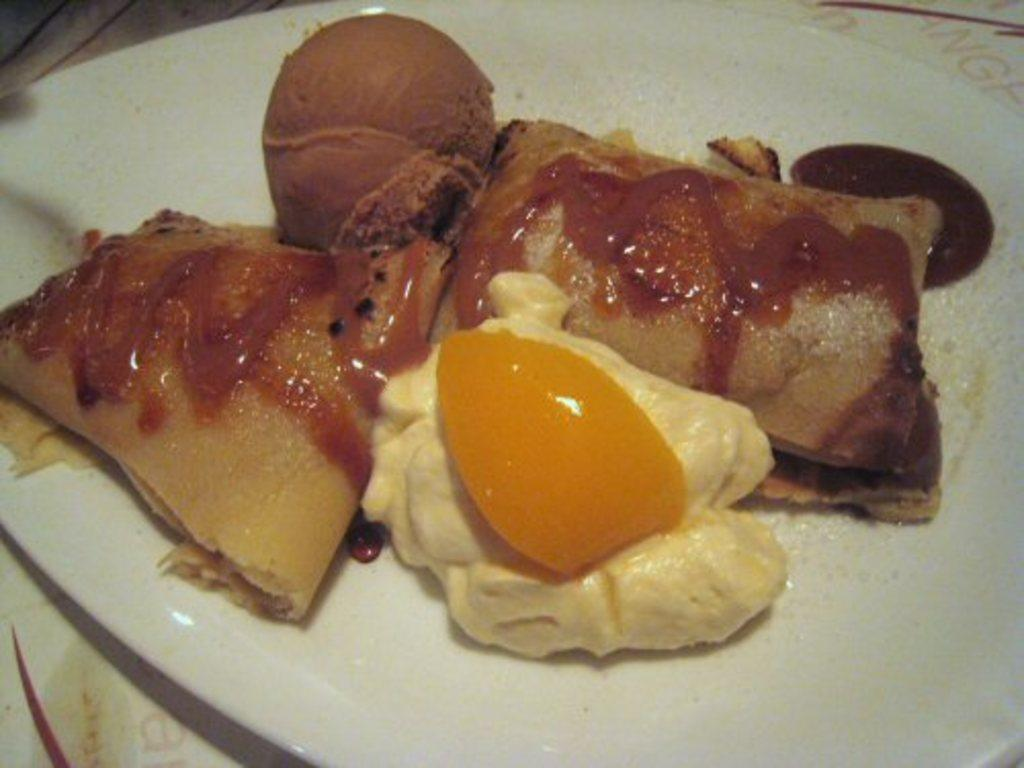How close is the view of the image? The image is zoomed in. What is the main object in the foreground of the image? There is a white color palette in the foreground of the image. What can be found on the palette? The palette contains food items. Can you see the root of the tree in the image? There is no tree or root present in the image; it features a white color palette with food items. How does the person in the image touch the food items on the palette? There is no person present in the image, so it is not possible to determine how they would touch the food items. 